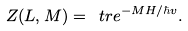<formula> <loc_0><loc_0><loc_500><loc_500>Z ( L , M ) = \ t r e ^ { - M H / { \hbar { v } } } .</formula> 